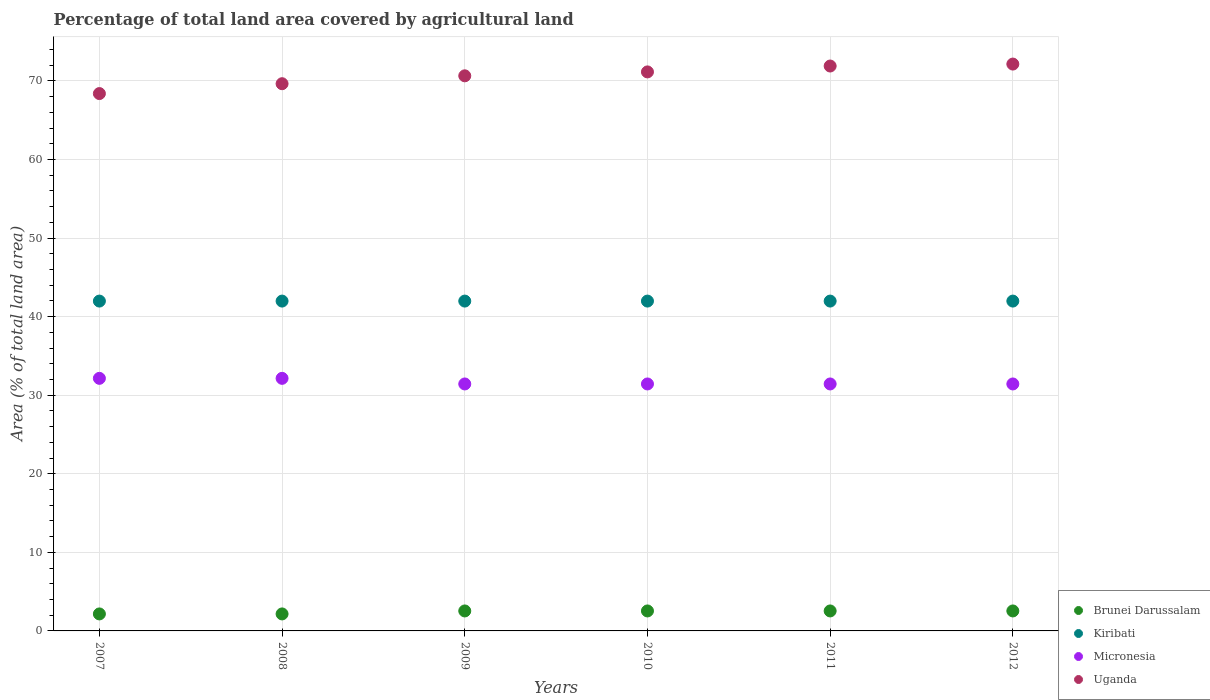Is the number of dotlines equal to the number of legend labels?
Your response must be concise. Yes. What is the percentage of agricultural land in Brunei Darussalam in 2008?
Provide a succinct answer. 2.16. Across all years, what is the maximum percentage of agricultural land in Kiribati?
Offer a terse response. 41.98. Across all years, what is the minimum percentage of agricultural land in Uganda?
Make the answer very short. 68.38. What is the total percentage of agricultural land in Uganda in the graph?
Ensure brevity in your answer.  423.83. What is the difference between the percentage of agricultural land in Brunei Darussalam in 2008 and that in 2009?
Keep it short and to the point. -0.38. What is the difference between the percentage of agricultural land in Brunei Darussalam in 2011 and the percentage of agricultural land in Kiribati in 2009?
Provide a succinct answer. -39.43. What is the average percentage of agricultural land in Micronesia per year?
Offer a terse response. 31.67. In the year 2007, what is the difference between the percentage of agricultural land in Uganda and percentage of agricultural land in Kiribati?
Ensure brevity in your answer.  26.41. In how many years, is the percentage of agricultural land in Kiribati greater than 66 %?
Provide a short and direct response. 0. What is the ratio of the percentage of agricultural land in Micronesia in 2008 to that in 2011?
Offer a very short reply. 1.02. Is the percentage of agricultural land in Kiribati in 2009 less than that in 2011?
Make the answer very short. No. What is the difference between the highest and the lowest percentage of agricultural land in Micronesia?
Ensure brevity in your answer.  0.71. In how many years, is the percentage of agricultural land in Uganda greater than the average percentage of agricultural land in Uganda taken over all years?
Give a very brief answer. 4. Is it the case that in every year, the sum of the percentage of agricultural land in Brunei Darussalam and percentage of agricultural land in Micronesia  is greater than the sum of percentage of agricultural land in Kiribati and percentage of agricultural land in Uganda?
Your answer should be very brief. No. Is it the case that in every year, the sum of the percentage of agricultural land in Uganda and percentage of agricultural land in Brunei Darussalam  is greater than the percentage of agricultural land in Micronesia?
Your response must be concise. Yes. Does the percentage of agricultural land in Brunei Darussalam monotonically increase over the years?
Ensure brevity in your answer.  No. How many dotlines are there?
Your answer should be compact. 4. How many years are there in the graph?
Provide a short and direct response. 6. Does the graph contain any zero values?
Ensure brevity in your answer.  No. Does the graph contain grids?
Provide a succinct answer. Yes. How are the legend labels stacked?
Your answer should be compact. Vertical. What is the title of the graph?
Provide a succinct answer. Percentage of total land area covered by agricultural land. Does "Fiji" appear as one of the legend labels in the graph?
Offer a very short reply. No. What is the label or title of the X-axis?
Your answer should be compact. Years. What is the label or title of the Y-axis?
Give a very brief answer. Area (% of total land area). What is the Area (% of total land area) of Brunei Darussalam in 2007?
Make the answer very short. 2.16. What is the Area (% of total land area) of Kiribati in 2007?
Provide a succinct answer. 41.98. What is the Area (% of total land area) in Micronesia in 2007?
Provide a short and direct response. 32.14. What is the Area (% of total land area) in Uganda in 2007?
Provide a succinct answer. 68.38. What is the Area (% of total land area) in Brunei Darussalam in 2008?
Your answer should be very brief. 2.16. What is the Area (% of total land area) of Kiribati in 2008?
Your answer should be very brief. 41.98. What is the Area (% of total land area) of Micronesia in 2008?
Your answer should be compact. 32.14. What is the Area (% of total land area) of Uganda in 2008?
Your answer should be very brief. 69.64. What is the Area (% of total land area) of Brunei Darussalam in 2009?
Make the answer very short. 2.54. What is the Area (% of total land area) in Kiribati in 2009?
Provide a short and direct response. 41.98. What is the Area (% of total land area) of Micronesia in 2009?
Keep it short and to the point. 31.43. What is the Area (% of total land area) of Uganda in 2009?
Your answer should be compact. 70.64. What is the Area (% of total land area) in Brunei Darussalam in 2010?
Your answer should be very brief. 2.54. What is the Area (% of total land area) of Kiribati in 2010?
Offer a very short reply. 41.98. What is the Area (% of total land area) in Micronesia in 2010?
Give a very brief answer. 31.43. What is the Area (% of total land area) in Uganda in 2010?
Provide a succinct answer. 71.14. What is the Area (% of total land area) in Brunei Darussalam in 2011?
Provide a short and direct response. 2.54. What is the Area (% of total land area) in Kiribati in 2011?
Make the answer very short. 41.98. What is the Area (% of total land area) in Micronesia in 2011?
Give a very brief answer. 31.43. What is the Area (% of total land area) in Uganda in 2011?
Your response must be concise. 71.89. What is the Area (% of total land area) of Brunei Darussalam in 2012?
Provide a succinct answer. 2.54. What is the Area (% of total land area) in Kiribati in 2012?
Keep it short and to the point. 41.98. What is the Area (% of total land area) of Micronesia in 2012?
Provide a short and direct response. 31.43. What is the Area (% of total land area) of Uganda in 2012?
Provide a short and direct response. 72.14. Across all years, what is the maximum Area (% of total land area) of Brunei Darussalam?
Offer a terse response. 2.54. Across all years, what is the maximum Area (% of total land area) in Kiribati?
Offer a very short reply. 41.98. Across all years, what is the maximum Area (% of total land area) of Micronesia?
Your answer should be compact. 32.14. Across all years, what is the maximum Area (% of total land area) of Uganda?
Provide a short and direct response. 72.14. Across all years, what is the minimum Area (% of total land area) of Brunei Darussalam?
Give a very brief answer. 2.16. Across all years, what is the minimum Area (% of total land area) in Kiribati?
Your answer should be compact. 41.98. Across all years, what is the minimum Area (% of total land area) of Micronesia?
Your response must be concise. 31.43. Across all years, what is the minimum Area (% of total land area) in Uganda?
Offer a very short reply. 68.38. What is the total Area (% of total land area) of Brunei Darussalam in the graph?
Your response must be concise. 14.5. What is the total Area (% of total land area) of Kiribati in the graph?
Give a very brief answer. 251.85. What is the total Area (% of total land area) of Micronesia in the graph?
Your answer should be very brief. 190. What is the total Area (% of total land area) in Uganda in the graph?
Your answer should be compact. 423.83. What is the difference between the Area (% of total land area) in Brunei Darussalam in 2007 and that in 2008?
Keep it short and to the point. 0. What is the difference between the Area (% of total land area) in Kiribati in 2007 and that in 2008?
Your answer should be very brief. 0. What is the difference between the Area (% of total land area) in Micronesia in 2007 and that in 2008?
Your answer should be very brief. 0. What is the difference between the Area (% of total land area) in Uganda in 2007 and that in 2008?
Give a very brief answer. -1.25. What is the difference between the Area (% of total land area) of Brunei Darussalam in 2007 and that in 2009?
Offer a very short reply. -0.38. What is the difference between the Area (% of total land area) of Kiribati in 2007 and that in 2009?
Provide a short and direct response. 0. What is the difference between the Area (% of total land area) in Uganda in 2007 and that in 2009?
Ensure brevity in your answer.  -2.26. What is the difference between the Area (% of total land area) of Brunei Darussalam in 2007 and that in 2010?
Your answer should be very brief. -0.38. What is the difference between the Area (% of total land area) in Kiribati in 2007 and that in 2010?
Make the answer very short. 0. What is the difference between the Area (% of total land area) of Uganda in 2007 and that in 2010?
Offer a very short reply. -2.76. What is the difference between the Area (% of total land area) of Brunei Darussalam in 2007 and that in 2011?
Make the answer very short. -0.38. What is the difference between the Area (% of total land area) in Micronesia in 2007 and that in 2011?
Provide a short and direct response. 0.71. What is the difference between the Area (% of total land area) in Uganda in 2007 and that in 2011?
Keep it short and to the point. -3.51. What is the difference between the Area (% of total land area) of Brunei Darussalam in 2007 and that in 2012?
Your answer should be compact. -0.38. What is the difference between the Area (% of total land area) in Kiribati in 2007 and that in 2012?
Your answer should be very brief. 0. What is the difference between the Area (% of total land area) in Micronesia in 2007 and that in 2012?
Your answer should be compact. 0.71. What is the difference between the Area (% of total land area) in Uganda in 2007 and that in 2012?
Provide a short and direct response. -3.75. What is the difference between the Area (% of total land area) of Brunei Darussalam in 2008 and that in 2009?
Give a very brief answer. -0.38. What is the difference between the Area (% of total land area) in Kiribati in 2008 and that in 2009?
Provide a short and direct response. 0. What is the difference between the Area (% of total land area) in Micronesia in 2008 and that in 2009?
Provide a succinct answer. 0.71. What is the difference between the Area (% of total land area) of Uganda in 2008 and that in 2009?
Ensure brevity in your answer.  -1. What is the difference between the Area (% of total land area) of Brunei Darussalam in 2008 and that in 2010?
Provide a short and direct response. -0.38. What is the difference between the Area (% of total land area) in Micronesia in 2008 and that in 2010?
Provide a short and direct response. 0.71. What is the difference between the Area (% of total land area) of Uganda in 2008 and that in 2010?
Make the answer very short. -1.5. What is the difference between the Area (% of total land area) in Brunei Darussalam in 2008 and that in 2011?
Provide a succinct answer. -0.38. What is the difference between the Area (% of total land area) of Uganda in 2008 and that in 2011?
Make the answer very short. -2.25. What is the difference between the Area (% of total land area) of Brunei Darussalam in 2008 and that in 2012?
Ensure brevity in your answer.  -0.38. What is the difference between the Area (% of total land area) in Kiribati in 2008 and that in 2012?
Keep it short and to the point. 0. What is the difference between the Area (% of total land area) in Micronesia in 2008 and that in 2012?
Give a very brief answer. 0.71. What is the difference between the Area (% of total land area) in Uganda in 2008 and that in 2012?
Provide a succinct answer. -2.5. What is the difference between the Area (% of total land area) of Brunei Darussalam in 2009 and that in 2010?
Give a very brief answer. 0. What is the difference between the Area (% of total land area) of Micronesia in 2009 and that in 2010?
Keep it short and to the point. 0. What is the difference between the Area (% of total land area) in Uganda in 2009 and that in 2010?
Your response must be concise. -0.5. What is the difference between the Area (% of total land area) in Brunei Darussalam in 2009 and that in 2011?
Offer a terse response. 0. What is the difference between the Area (% of total land area) in Micronesia in 2009 and that in 2011?
Your answer should be very brief. 0. What is the difference between the Area (% of total land area) in Uganda in 2009 and that in 2011?
Keep it short and to the point. -1.25. What is the difference between the Area (% of total land area) of Uganda in 2009 and that in 2012?
Your response must be concise. -1.5. What is the difference between the Area (% of total land area) of Kiribati in 2010 and that in 2011?
Your answer should be compact. 0. What is the difference between the Area (% of total land area) of Uganda in 2010 and that in 2011?
Your answer should be compact. -0.75. What is the difference between the Area (% of total land area) of Brunei Darussalam in 2010 and that in 2012?
Give a very brief answer. 0. What is the difference between the Area (% of total land area) in Kiribati in 2010 and that in 2012?
Make the answer very short. 0. What is the difference between the Area (% of total land area) in Uganda in 2010 and that in 2012?
Keep it short and to the point. -1. What is the difference between the Area (% of total land area) of Uganda in 2011 and that in 2012?
Give a very brief answer. -0.25. What is the difference between the Area (% of total land area) in Brunei Darussalam in 2007 and the Area (% of total land area) in Kiribati in 2008?
Offer a very short reply. -39.81. What is the difference between the Area (% of total land area) of Brunei Darussalam in 2007 and the Area (% of total land area) of Micronesia in 2008?
Offer a terse response. -29.98. What is the difference between the Area (% of total land area) of Brunei Darussalam in 2007 and the Area (% of total land area) of Uganda in 2008?
Give a very brief answer. -67.47. What is the difference between the Area (% of total land area) in Kiribati in 2007 and the Area (% of total land area) in Micronesia in 2008?
Provide a short and direct response. 9.83. What is the difference between the Area (% of total land area) of Kiribati in 2007 and the Area (% of total land area) of Uganda in 2008?
Provide a short and direct response. -27.66. What is the difference between the Area (% of total land area) in Micronesia in 2007 and the Area (% of total land area) in Uganda in 2008?
Ensure brevity in your answer.  -37.49. What is the difference between the Area (% of total land area) of Brunei Darussalam in 2007 and the Area (% of total land area) of Kiribati in 2009?
Provide a short and direct response. -39.81. What is the difference between the Area (% of total land area) in Brunei Darussalam in 2007 and the Area (% of total land area) in Micronesia in 2009?
Keep it short and to the point. -29.27. What is the difference between the Area (% of total land area) of Brunei Darussalam in 2007 and the Area (% of total land area) of Uganda in 2009?
Keep it short and to the point. -68.48. What is the difference between the Area (% of total land area) of Kiribati in 2007 and the Area (% of total land area) of Micronesia in 2009?
Your answer should be compact. 10.55. What is the difference between the Area (% of total land area) of Kiribati in 2007 and the Area (% of total land area) of Uganda in 2009?
Provide a short and direct response. -28.67. What is the difference between the Area (% of total land area) in Micronesia in 2007 and the Area (% of total land area) in Uganda in 2009?
Your response must be concise. -38.5. What is the difference between the Area (% of total land area) in Brunei Darussalam in 2007 and the Area (% of total land area) in Kiribati in 2010?
Give a very brief answer. -39.81. What is the difference between the Area (% of total land area) in Brunei Darussalam in 2007 and the Area (% of total land area) in Micronesia in 2010?
Offer a terse response. -29.27. What is the difference between the Area (% of total land area) of Brunei Darussalam in 2007 and the Area (% of total land area) of Uganda in 2010?
Your response must be concise. -68.98. What is the difference between the Area (% of total land area) of Kiribati in 2007 and the Area (% of total land area) of Micronesia in 2010?
Ensure brevity in your answer.  10.55. What is the difference between the Area (% of total land area) of Kiribati in 2007 and the Area (% of total land area) of Uganda in 2010?
Your answer should be very brief. -29.16. What is the difference between the Area (% of total land area) in Micronesia in 2007 and the Area (% of total land area) in Uganda in 2010?
Offer a very short reply. -39. What is the difference between the Area (% of total land area) of Brunei Darussalam in 2007 and the Area (% of total land area) of Kiribati in 2011?
Offer a very short reply. -39.81. What is the difference between the Area (% of total land area) of Brunei Darussalam in 2007 and the Area (% of total land area) of Micronesia in 2011?
Offer a terse response. -29.27. What is the difference between the Area (% of total land area) of Brunei Darussalam in 2007 and the Area (% of total land area) of Uganda in 2011?
Your answer should be compact. -69.72. What is the difference between the Area (% of total land area) of Kiribati in 2007 and the Area (% of total land area) of Micronesia in 2011?
Your answer should be very brief. 10.55. What is the difference between the Area (% of total land area) of Kiribati in 2007 and the Area (% of total land area) of Uganda in 2011?
Give a very brief answer. -29.91. What is the difference between the Area (% of total land area) in Micronesia in 2007 and the Area (% of total land area) in Uganda in 2011?
Offer a terse response. -39.75. What is the difference between the Area (% of total land area) in Brunei Darussalam in 2007 and the Area (% of total land area) in Kiribati in 2012?
Offer a terse response. -39.81. What is the difference between the Area (% of total land area) in Brunei Darussalam in 2007 and the Area (% of total land area) in Micronesia in 2012?
Keep it short and to the point. -29.27. What is the difference between the Area (% of total land area) of Brunei Darussalam in 2007 and the Area (% of total land area) of Uganda in 2012?
Make the answer very short. -69.97. What is the difference between the Area (% of total land area) in Kiribati in 2007 and the Area (% of total land area) in Micronesia in 2012?
Offer a terse response. 10.55. What is the difference between the Area (% of total land area) in Kiribati in 2007 and the Area (% of total land area) in Uganda in 2012?
Your answer should be very brief. -30.16. What is the difference between the Area (% of total land area) in Micronesia in 2007 and the Area (% of total land area) in Uganda in 2012?
Give a very brief answer. -39.99. What is the difference between the Area (% of total land area) in Brunei Darussalam in 2008 and the Area (% of total land area) in Kiribati in 2009?
Provide a succinct answer. -39.81. What is the difference between the Area (% of total land area) in Brunei Darussalam in 2008 and the Area (% of total land area) in Micronesia in 2009?
Provide a succinct answer. -29.27. What is the difference between the Area (% of total land area) in Brunei Darussalam in 2008 and the Area (% of total land area) in Uganda in 2009?
Your answer should be compact. -68.48. What is the difference between the Area (% of total land area) in Kiribati in 2008 and the Area (% of total land area) in Micronesia in 2009?
Provide a succinct answer. 10.55. What is the difference between the Area (% of total land area) of Kiribati in 2008 and the Area (% of total land area) of Uganda in 2009?
Offer a very short reply. -28.67. What is the difference between the Area (% of total land area) of Micronesia in 2008 and the Area (% of total land area) of Uganda in 2009?
Give a very brief answer. -38.5. What is the difference between the Area (% of total land area) in Brunei Darussalam in 2008 and the Area (% of total land area) in Kiribati in 2010?
Offer a terse response. -39.81. What is the difference between the Area (% of total land area) of Brunei Darussalam in 2008 and the Area (% of total land area) of Micronesia in 2010?
Offer a very short reply. -29.27. What is the difference between the Area (% of total land area) in Brunei Darussalam in 2008 and the Area (% of total land area) in Uganda in 2010?
Your answer should be very brief. -68.98. What is the difference between the Area (% of total land area) in Kiribati in 2008 and the Area (% of total land area) in Micronesia in 2010?
Ensure brevity in your answer.  10.55. What is the difference between the Area (% of total land area) in Kiribati in 2008 and the Area (% of total land area) in Uganda in 2010?
Your answer should be very brief. -29.16. What is the difference between the Area (% of total land area) of Micronesia in 2008 and the Area (% of total land area) of Uganda in 2010?
Your answer should be very brief. -39. What is the difference between the Area (% of total land area) of Brunei Darussalam in 2008 and the Area (% of total land area) of Kiribati in 2011?
Your response must be concise. -39.81. What is the difference between the Area (% of total land area) in Brunei Darussalam in 2008 and the Area (% of total land area) in Micronesia in 2011?
Offer a terse response. -29.27. What is the difference between the Area (% of total land area) in Brunei Darussalam in 2008 and the Area (% of total land area) in Uganda in 2011?
Your answer should be very brief. -69.72. What is the difference between the Area (% of total land area) of Kiribati in 2008 and the Area (% of total land area) of Micronesia in 2011?
Your answer should be very brief. 10.55. What is the difference between the Area (% of total land area) in Kiribati in 2008 and the Area (% of total land area) in Uganda in 2011?
Your answer should be compact. -29.91. What is the difference between the Area (% of total land area) of Micronesia in 2008 and the Area (% of total land area) of Uganda in 2011?
Your response must be concise. -39.75. What is the difference between the Area (% of total land area) of Brunei Darussalam in 2008 and the Area (% of total land area) of Kiribati in 2012?
Your response must be concise. -39.81. What is the difference between the Area (% of total land area) in Brunei Darussalam in 2008 and the Area (% of total land area) in Micronesia in 2012?
Your answer should be compact. -29.27. What is the difference between the Area (% of total land area) in Brunei Darussalam in 2008 and the Area (% of total land area) in Uganda in 2012?
Your answer should be compact. -69.97. What is the difference between the Area (% of total land area) of Kiribati in 2008 and the Area (% of total land area) of Micronesia in 2012?
Your response must be concise. 10.55. What is the difference between the Area (% of total land area) of Kiribati in 2008 and the Area (% of total land area) of Uganda in 2012?
Provide a short and direct response. -30.16. What is the difference between the Area (% of total land area) in Micronesia in 2008 and the Area (% of total land area) in Uganda in 2012?
Your answer should be compact. -39.99. What is the difference between the Area (% of total land area) in Brunei Darussalam in 2009 and the Area (% of total land area) in Kiribati in 2010?
Offer a terse response. -39.43. What is the difference between the Area (% of total land area) in Brunei Darussalam in 2009 and the Area (% of total land area) in Micronesia in 2010?
Ensure brevity in your answer.  -28.89. What is the difference between the Area (% of total land area) in Brunei Darussalam in 2009 and the Area (% of total land area) in Uganda in 2010?
Your answer should be compact. -68.6. What is the difference between the Area (% of total land area) in Kiribati in 2009 and the Area (% of total land area) in Micronesia in 2010?
Give a very brief answer. 10.55. What is the difference between the Area (% of total land area) of Kiribati in 2009 and the Area (% of total land area) of Uganda in 2010?
Make the answer very short. -29.16. What is the difference between the Area (% of total land area) in Micronesia in 2009 and the Area (% of total land area) in Uganda in 2010?
Keep it short and to the point. -39.71. What is the difference between the Area (% of total land area) in Brunei Darussalam in 2009 and the Area (% of total land area) in Kiribati in 2011?
Make the answer very short. -39.43. What is the difference between the Area (% of total land area) in Brunei Darussalam in 2009 and the Area (% of total land area) in Micronesia in 2011?
Make the answer very short. -28.89. What is the difference between the Area (% of total land area) in Brunei Darussalam in 2009 and the Area (% of total land area) in Uganda in 2011?
Provide a succinct answer. -69.35. What is the difference between the Area (% of total land area) of Kiribati in 2009 and the Area (% of total land area) of Micronesia in 2011?
Give a very brief answer. 10.55. What is the difference between the Area (% of total land area) in Kiribati in 2009 and the Area (% of total land area) in Uganda in 2011?
Provide a short and direct response. -29.91. What is the difference between the Area (% of total land area) of Micronesia in 2009 and the Area (% of total land area) of Uganda in 2011?
Keep it short and to the point. -40.46. What is the difference between the Area (% of total land area) in Brunei Darussalam in 2009 and the Area (% of total land area) in Kiribati in 2012?
Your answer should be compact. -39.43. What is the difference between the Area (% of total land area) of Brunei Darussalam in 2009 and the Area (% of total land area) of Micronesia in 2012?
Provide a short and direct response. -28.89. What is the difference between the Area (% of total land area) of Brunei Darussalam in 2009 and the Area (% of total land area) of Uganda in 2012?
Give a very brief answer. -69.59. What is the difference between the Area (% of total land area) of Kiribati in 2009 and the Area (% of total land area) of Micronesia in 2012?
Give a very brief answer. 10.55. What is the difference between the Area (% of total land area) of Kiribati in 2009 and the Area (% of total land area) of Uganda in 2012?
Your response must be concise. -30.16. What is the difference between the Area (% of total land area) of Micronesia in 2009 and the Area (% of total land area) of Uganda in 2012?
Keep it short and to the point. -40.71. What is the difference between the Area (% of total land area) of Brunei Darussalam in 2010 and the Area (% of total land area) of Kiribati in 2011?
Keep it short and to the point. -39.43. What is the difference between the Area (% of total land area) of Brunei Darussalam in 2010 and the Area (% of total land area) of Micronesia in 2011?
Give a very brief answer. -28.89. What is the difference between the Area (% of total land area) in Brunei Darussalam in 2010 and the Area (% of total land area) in Uganda in 2011?
Provide a succinct answer. -69.35. What is the difference between the Area (% of total land area) in Kiribati in 2010 and the Area (% of total land area) in Micronesia in 2011?
Your response must be concise. 10.55. What is the difference between the Area (% of total land area) in Kiribati in 2010 and the Area (% of total land area) in Uganda in 2011?
Give a very brief answer. -29.91. What is the difference between the Area (% of total land area) of Micronesia in 2010 and the Area (% of total land area) of Uganda in 2011?
Offer a terse response. -40.46. What is the difference between the Area (% of total land area) of Brunei Darussalam in 2010 and the Area (% of total land area) of Kiribati in 2012?
Give a very brief answer. -39.43. What is the difference between the Area (% of total land area) of Brunei Darussalam in 2010 and the Area (% of total land area) of Micronesia in 2012?
Your response must be concise. -28.89. What is the difference between the Area (% of total land area) in Brunei Darussalam in 2010 and the Area (% of total land area) in Uganda in 2012?
Provide a succinct answer. -69.59. What is the difference between the Area (% of total land area) in Kiribati in 2010 and the Area (% of total land area) in Micronesia in 2012?
Keep it short and to the point. 10.55. What is the difference between the Area (% of total land area) of Kiribati in 2010 and the Area (% of total land area) of Uganda in 2012?
Give a very brief answer. -30.16. What is the difference between the Area (% of total land area) in Micronesia in 2010 and the Area (% of total land area) in Uganda in 2012?
Offer a very short reply. -40.71. What is the difference between the Area (% of total land area) in Brunei Darussalam in 2011 and the Area (% of total land area) in Kiribati in 2012?
Make the answer very short. -39.43. What is the difference between the Area (% of total land area) of Brunei Darussalam in 2011 and the Area (% of total land area) of Micronesia in 2012?
Ensure brevity in your answer.  -28.89. What is the difference between the Area (% of total land area) of Brunei Darussalam in 2011 and the Area (% of total land area) of Uganda in 2012?
Offer a terse response. -69.59. What is the difference between the Area (% of total land area) in Kiribati in 2011 and the Area (% of total land area) in Micronesia in 2012?
Your answer should be compact. 10.55. What is the difference between the Area (% of total land area) in Kiribati in 2011 and the Area (% of total land area) in Uganda in 2012?
Provide a short and direct response. -30.16. What is the difference between the Area (% of total land area) of Micronesia in 2011 and the Area (% of total land area) of Uganda in 2012?
Offer a terse response. -40.71. What is the average Area (% of total land area) in Brunei Darussalam per year?
Your response must be concise. 2.42. What is the average Area (% of total land area) in Kiribati per year?
Ensure brevity in your answer.  41.98. What is the average Area (% of total land area) in Micronesia per year?
Ensure brevity in your answer.  31.67. What is the average Area (% of total land area) of Uganda per year?
Your answer should be very brief. 70.64. In the year 2007, what is the difference between the Area (% of total land area) of Brunei Darussalam and Area (% of total land area) of Kiribati?
Provide a short and direct response. -39.81. In the year 2007, what is the difference between the Area (% of total land area) of Brunei Darussalam and Area (% of total land area) of Micronesia?
Ensure brevity in your answer.  -29.98. In the year 2007, what is the difference between the Area (% of total land area) of Brunei Darussalam and Area (% of total land area) of Uganda?
Keep it short and to the point. -66.22. In the year 2007, what is the difference between the Area (% of total land area) of Kiribati and Area (% of total land area) of Micronesia?
Provide a succinct answer. 9.83. In the year 2007, what is the difference between the Area (% of total land area) in Kiribati and Area (% of total land area) in Uganda?
Offer a very short reply. -26.41. In the year 2007, what is the difference between the Area (% of total land area) of Micronesia and Area (% of total land area) of Uganda?
Make the answer very short. -36.24. In the year 2008, what is the difference between the Area (% of total land area) in Brunei Darussalam and Area (% of total land area) in Kiribati?
Your answer should be compact. -39.81. In the year 2008, what is the difference between the Area (% of total land area) in Brunei Darussalam and Area (% of total land area) in Micronesia?
Keep it short and to the point. -29.98. In the year 2008, what is the difference between the Area (% of total land area) of Brunei Darussalam and Area (% of total land area) of Uganda?
Your answer should be very brief. -67.47. In the year 2008, what is the difference between the Area (% of total land area) of Kiribati and Area (% of total land area) of Micronesia?
Your response must be concise. 9.83. In the year 2008, what is the difference between the Area (% of total land area) in Kiribati and Area (% of total land area) in Uganda?
Provide a succinct answer. -27.66. In the year 2008, what is the difference between the Area (% of total land area) in Micronesia and Area (% of total land area) in Uganda?
Provide a succinct answer. -37.49. In the year 2009, what is the difference between the Area (% of total land area) in Brunei Darussalam and Area (% of total land area) in Kiribati?
Provide a succinct answer. -39.43. In the year 2009, what is the difference between the Area (% of total land area) in Brunei Darussalam and Area (% of total land area) in Micronesia?
Provide a short and direct response. -28.89. In the year 2009, what is the difference between the Area (% of total land area) in Brunei Darussalam and Area (% of total land area) in Uganda?
Provide a succinct answer. -68.1. In the year 2009, what is the difference between the Area (% of total land area) in Kiribati and Area (% of total land area) in Micronesia?
Make the answer very short. 10.55. In the year 2009, what is the difference between the Area (% of total land area) of Kiribati and Area (% of total land area) of Uganda?
Keep it short and to the point. -28.67. In the year 2009, what is the difference between the Area (% of total land area) in Micronesia and Area (% of total land area) in Uganda?
Offer a terse response. -39.21. In the year 2010, what is the difference between the Area (% of total land area) in Brunei Darussalam and Area (% of total land area) in Kiribati?
Provide a succinct answer. -39.43. In the year 2010, what is the difference between the Area (% of total land area) in Brunei Darussalam and Area (% of total land area) in Micronesia?
Your answer should be very brief. -28.89. In the year 2010, what is the difference between the Area (% of total land area) in Brunei Darussalam and Area (% of total land area) in Uganda?
Give a very brief answer. -68.6. In the year 2010, what is the difference between the Area (% of total land area) of Kiribati and Area (% of total land area) of Micronesia?
Your response must be concise. 10.55. In the year 2010, what is the difference between the Area (% of total land area) in Kiribati and Area (% of total land area) in Uganda?
Provide a short and direct response. -29.16. In the year 2010, what is the difference between the Area (% of total land area) in Micronesia and Area (% of total land area) in Uganda?
Your answer should be very brief. -39.71. In the year 2011, what is the difference between the Area (% of total land area) of Brunei Darussalam and Area (% of total land area) of Kiribati?
Give a very brief answer. -39.43. In the year 2011, what is the difference between the Area (% of total land area) in Brunei Darussalam and Area (% of total land area) in Micronesia?
Your answer should be compact. -28.89. In the year 2011, what is the difference between the Area (% of total land area) of Brunei Darussalam and Area (% of total land area) of Uganda?
Your answer should be compact. -69.35. In the year 2011, what is the difference between the Area (% of total land area) in Kiribati and Area (% of total land area) in Micronesia?
Offer a terse response. 10.55. In the year 2011, what is the difference between the Area (% of total land area) in Kiribati and Area (% of total land area) in Uganda?
Offer a very short reply. -29.91. In the year 2011, what is the difference between the Area (% of total land area) in Micronesia and Area (% of total land area) in Uganda?
Provide a short and direct response. -40.46. In the year 2012, what is the difference between the Area (% of total land area) in Brunei Darussalam and Area (% of total land area) in Kiribati?
Give a very brief answer. -39.43. In the year 2012, what is the difference between the Area (% of total land area) in Brunei Darussalam and Area (% of total land area) in Micronesia?
Make the answer very short. -28.89. In the year 2012, what is the difference between the Area (% of total land area) of Brunei Darussalam and Area (% of total land area) of Uganda?
Ensure brevity in your answer.  -69.59. In the year 2012, what is the difference between the Area (% of total land area) in Kiribati and Area (% of total land area) in Micronesia?
Provide a succinct answer. 10.55. In the year 2012, what is the difference between the Area (% of total land area) in Kiribati and Area (% of total land area) in Uganda?
Make the answer very short. -30.16. In the year 2012, what is the difference between the Area (% of total land area) of Micronesia and Area (% of total land area) of Uganda?
Provide a succinct answer. -40.71. What is the ratio of the Area (% of total land area) of Kiribati in 2007 to that in 2008?
Offer a very short reply. 1. What is the ratio of the Area (% of total land area) of Micronesia in 2007 to that in 2008?
Offer a terse response. 1. What is the ratio of the Area (% of total land area) in Uganda in 2007 to that in 2008?
Provide a short and direct response. 0.98. What is the ratio of the Area (% of total land area) of Brunei Darussalam in 2007 to that in 2009?
Your answer should be very brief. 0.85. What is the ratio of the Area (% of total land area) in Micronesia in 2007 to that in 2009?
Your answer should be very brief. 1.02. What is the ratio of the Area (% of total land area) of Brunei Darussalam in 2007 to that in 2010?
Give a very brief answer. 0.85. What is the ratio of the Area (% of total land area) of Micronesia in 2007 to that in 2010?
Provide a short and direct response. 1.02. What is the ratio of the Area (% of total land area) of Uganda in 2007 to that in 2010?
Your response must be concise. 0.96. What is the ratio of the Area (% of total land area) in Brunei Darussalam in 2007 to that in 2011?
Offer a very short reply. 0.85. What is the ratio of the Area (% of total land area) in Micronesia in 2007 to that in 2011?
Give a very brief answer. 1.02. What is the ratio of the Area (% of total land area) in Uganda in 2007 to that in 2011?
Your answer should be compact. 0.95. What is the ratio of the Area (% of total land area) of Brunei Darussalam in 2007 to that in 2012?
Ensure brevity in your answer.  0.85. What is the ratio of the Area (% of total land area) in Micronesia in 2007 to that in 2012?
Make the answer very short. 1.02. What is the ratio of the Area (% of total land area) in Uganda in 2007 to that in 2012?
Your response must be concise. 0.95. What is the ratio of the Area (% of total land area) of Brunei Darussalam in 2008 to that in 2009?
Give a very brief answer. 0.85. What is the ratio of the Area (% of total land area) in Kiribati in 2008 to that in 2009?
Provide a succinct answer. 1. What is the ratio of the Area (% of total land area) of Micronesia in 2008 to that in 2009?
Keep it short and to the point. 1.02. What is the ratio of the Area (% of total land area) in Uganda in 2008 to that in 2009?
Provide a short and direct response. 0.99. What is the ratio of the Area (% of total land area) in Brunei Darussalam in 2008 to that in 2010?
Provide a succinct answer. 0.85. What is the ratio of the Area (% of total land area) in Micronesia in 2008 to that in 2010?
Provide a short and direct response. 1.02. What is the ratio of the Area (% of total land area) in Uganda in 2008 to that in 2010?
Your answer should be compact. 0.98. What is the ratio of the Area (% of total land area) in Brunei Darussalam in 2008 to that in 2011?
Offer a very short reply. 0.85. What is the ratio of the Area (% of total land area) of Micronesia in 2008 to that in 2011?
Your answer should be compact. 1.02. What is the ratio of the Area (% of total land area) of Uganda in 2008 to that in 2011?
Your answer should be compact. 0.97. What is the ratio of the Area (% of total land area) in Brunei Darussalam in 2008 to that in 2012?
Make the answer very short. 0.85. What is the ratio of the Area (% of total land area) in Kiribati in 2008 to that in 2012?
Your answer should be compact. 1. What is the ratio of the Area (% of total land area) of Micronesia in 2008 to that in 2012?
Offer a very short reply. 1.02. What is the ratio of the Area (% of total land area) in Uganda in 2008 to that in 2012?
Keep it short and to the point. 0.97. What is the ratio of the Area (% of total land area) of Brunei Darussalam in 2009 to that in 2010?
Offer a very short reply. 1. What is the ratio of the Area (% of total land area) in Kiribati in 2009 to that in 2010?
Make the answer very short. 1. What is the ratio of the Area (% of total land area) in Kiribati in 2009 to that in 2011?
Ensure brevity in your answer.  1. What is the ratio of the Area (% of total land area) in Uganda in 2009 to that in 2011?
Your answer should be very brief. 0.98. What is the ratio of the Area (% of total land area) of Kiribati in 2009 to that in 2012?
Provide a short and direct response. 1. What is the ratio of the Area (% of total land area) in Uganda in 2009 to that in 2012?
Your answer should be compact. 0.98. What is the ratio of the Area (% of total land area) in Brunei Darussalam in 2010 to that in 2011?
Keep it short and to the point. 1. What is the ratio of the Area (% of total land area) in Brunei Darussalam in 2010 to that in 2012?
Your answer should be very brief. 1. What is the ratio of the Area (% of total land area) of Uganda in 2010 to that in 2012?
Your answer should be compact. 0.99. What is the ratio of the Area (% of total land area) of Brunei Darussalam in 2011 to that in 2012?
Provide a short and direct response. 1. What is the ratio of the Area (% of total land area) of Kiribati in 2011 to that in 2012?
Provide a succinct answer. 1. What is the difference between the highest and the second highest Area (% of total land area) of Brunei Darussalam?
Your response must be concise. 0. What is the difference between the highest and the second highest Area (% of total land area) in Uganda?
Offer a terse response. 0.25. What is the difference between the highest and the lowest Area (% of total land area) in Brunei Darussalam?
Your response must be concise. 0.38. What is the difference between the highest and the lowest Area (% of total land area) in Kiribati?
Your answer should be compact. 0. What is the difference between the highest and the lowest Area (% of total land area) of Uganda?
Provide a short and direct response. 3.75. 